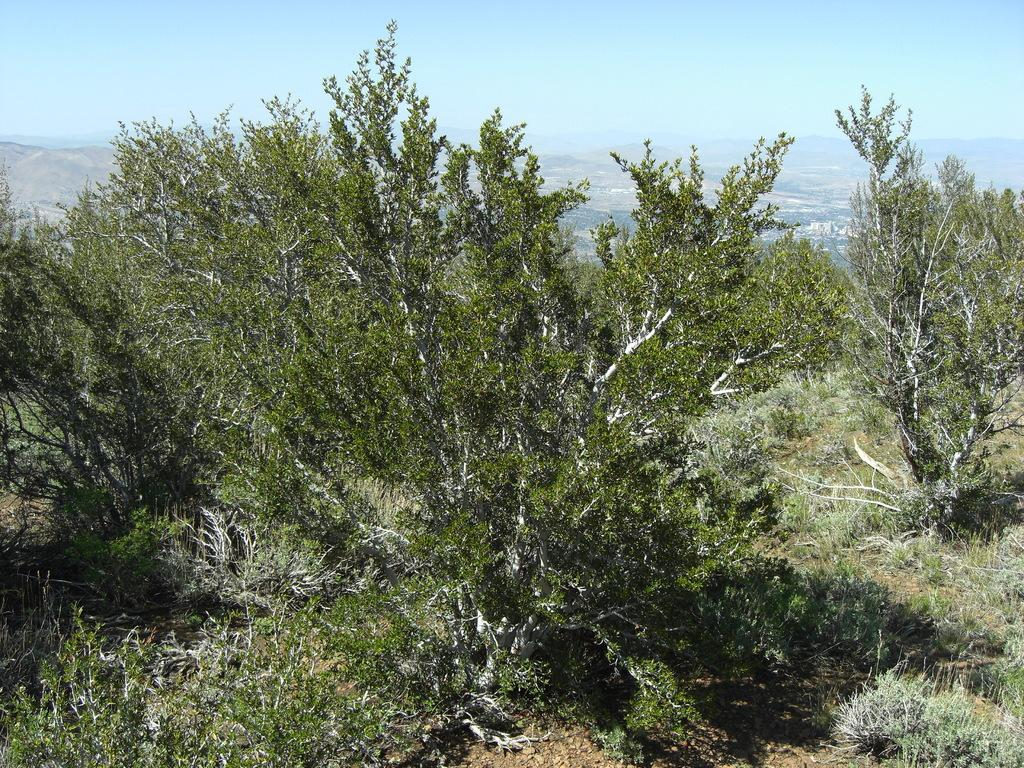What type of vegetation can be seen in the image? There are trees in the image. What else can be seen on the ground in the image? There is grass in the image. What type of geographical feature is visible in the distance? There are mountains in the image. What is the color of the sky in the image? The sky is blue and white in color. How much profit did the sidewalk generate in the image? There is no mention of a sidewalk or profit in the image; it features trees, grass, mountains, and a blue and white sky. 